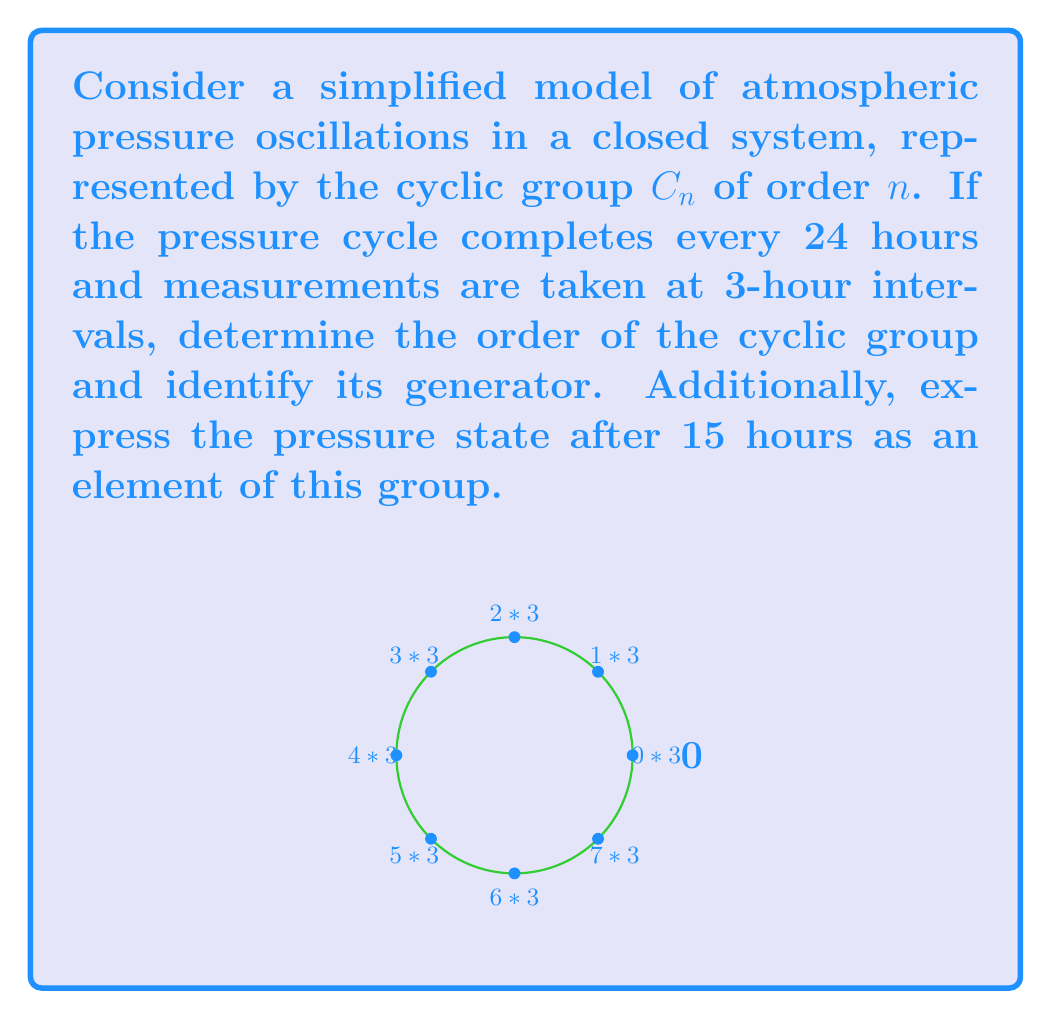Can you solve this math problem? Let's approach this step-by-step:

1) First, we need to determine the order of the cyclic group:
   - The cycle completes every 24 hours
   - Measurements are taken at 3-hour intervals
   - Number of distinct states = 24 / 3 = 8
   Therefore, the order of the cyclic group is 8, so we have $C_8$

2) The generator of this group will be the element that, when applied 8 times, completes the cycle. In this case, it's the 3-hour interval itself. Let's call this generator $g$.

3) We can represent the elements of $C_8$ as powers of $g$:
   $C_8 = \{e, g, g^2, g^3, g^4, g^5, g^6, g^7\}$
   where $e$ is the identity element (0 hours), $g$ is 3 hours, $g^2$ is 6 hours, and so on.

4) To express the pressure state after 15 hours:
   - 15 hours = 5 * 3 hours
   - This corresponds to applying the generator 5 times
   - In group notation, this is $g^5$

5) We can verify: $g^5 * g^3 = g^8 = e$, which completes the cycle back to the starting point (24 hours).
Answer: Order: 8, Generator: $g$ (3-hour interval), 15-hour state: $g^5$ 